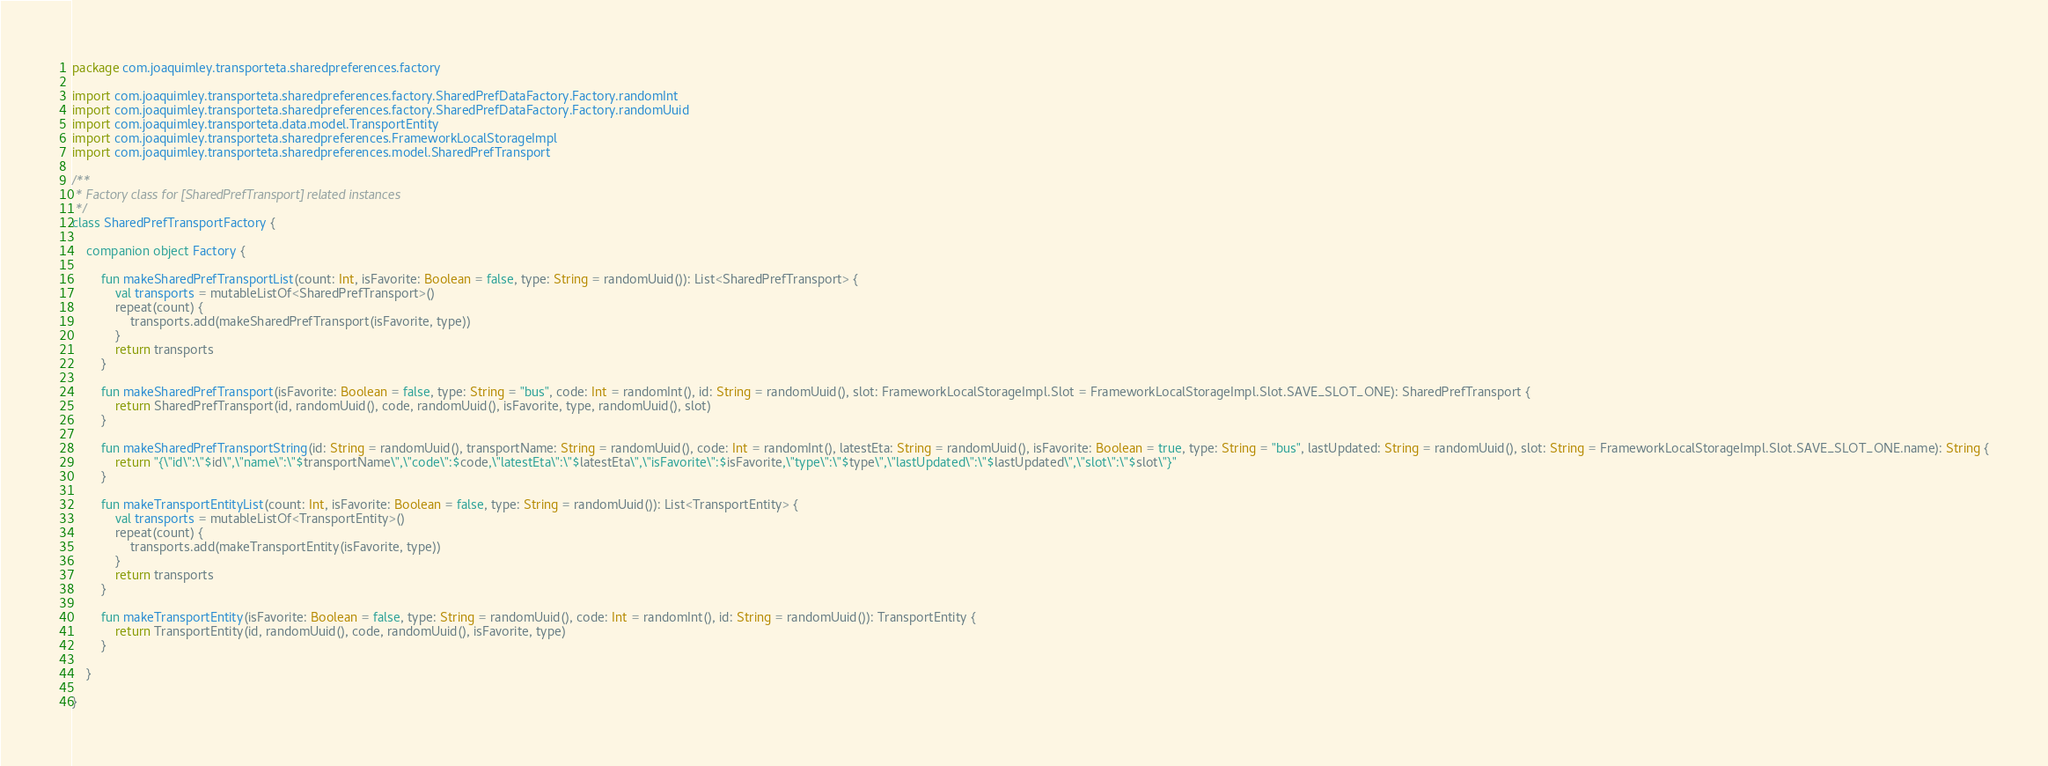<code> <loc_0><loc_0><loc_500><loc_500><_Kotlin_>package com.joaquimley.transporteta.sharedpreferences.factory

import com.joaquimley.transporteta.sharedpreferences.factory.SharedPrefDataFactory.Factory.randomInt
import com.joaquimley.transporteta.sharedpreferences.factory.SharedPrefDataFactory.Factory.randomUuid
import com.joaquimley.transporteta.data.model.TransportEntity
import com.joaquimley.transporteta.sharedpreferences.FrameworkLocalStorageImpl
import com.joaquimley.transporteta.sharedpreferences.model.SharedPrefTransport

/**
 * Factory class for [SharedPrefTransport] related instances
 */
class SharedPrefTransportFactory {

    companion object Factory {

        fun makeSharedPrefTransportList(count: Int, isFavorite: Boolean = false, type: String = randomUuid()): List<SharedPrefTransport> {
            val transports = mutableListOf<SharedPrefTransport>()
            repeat(count) {
                transports.add(makeSharedPrefTransport(isFavorite, type))
            }
            return transports
        }

        fun makeSharedPrefTransport(isFavorite: Boolean = false, type: String = "bus", code: Int = randomInt(), id: String = randomUuid(), slot: FrameworkLocalStorageImpl.Slot = FrameworkLocalStorageImpl.Slot.SAVE_SLOT_ONE): SharedPrefTransport {
            return SharedPrefTransport(id, randomUuid(), code, randomUuid(), isFavorite, type, randomUuid(), slot)
        }
        
        fun makeSharedPrefTransportString(id: String = randomUuid(), transportName: String = randomUuid(), code: Int = randomInt(), latestEta: String = randomUuid(), isFavorite: Boolean = true, type: String = "bus", lastUpdated: String = randomUuid(), slot: String = FrameworkLocalStorageImpl.Slot.SAVE_SLOT_ONE.name): String {
            return "{\"id\":\"$id\",\"name\":\"$transportName\",\"code\":$code,\"latestEta\":\"$latestEta\",\"isFavorite\":$isFavorite,\"type\":\"$type\",\"lastUpdated\":\"$lastUpdated\",\"slot\":\"$slot\"}"
        }

        fun makeTransportEntityList(count: Int, isFavorite: Boolean = false, type: String = randomUuid()): List<TransportEntity> {
            val transports = mutableListOf<TransportEntity>()
            repeat(count) {
                transports.add(makeTransportEntity(isFavorite, type))
            }
            return transports
        }

        fun makeTransportEntity(isFavorite: Boolean = false, type: String = randomUuid(), code: Int = randomInt(), id: String = randomUuid()): TransportEntity {
            return TransportEntity(id, randomUuid(), code, randomUuid(), isFavorite, type)
        }

    }

}</code> 